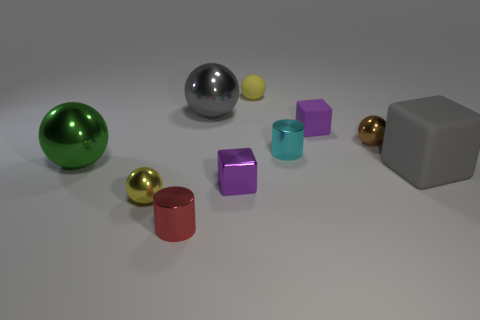Subtract 2 balls. How many balls are left? 3 Subtract all brown spheres. How many spheres are left? 4 Subtract all brown balls. How many balls are left? 4 Subtract all blue balls. Subtract all purple blocks. How many balls are left? 5 Subtract all blocks. How many objects are left? 7 Add 7 brown objects. How many brown objects are left? 8 Add 6 large gray metallic cubes. How many large gray metallic cubes exist? 6 Subtract 0 purple spheres. How many objects are left? 10 Subtract all big green spheres. Subtract all big green things. How many objects are left? 8 